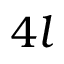<formula> <loc_0><loc_0><loc_500><loc_500>4 l</formula> 